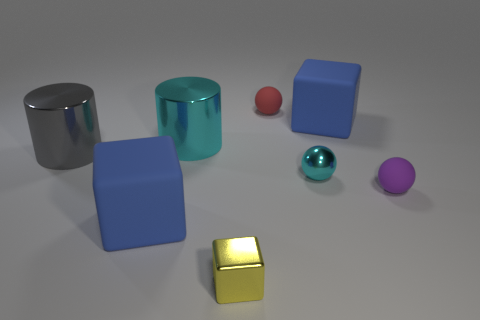What number of brown objects are metallic cylinders or tiny blocks?
Your answer should be very brief. 0. Is the number of big blue rubber objects that are left of the tiny purple thing less than the number of tiny purple balls that are behind the red thing?
Provide a succinct answer. No. Is there a red matte sphere that has the same size as the gray thing?
Offer a very short reply. No. Do the blue object that is in front of the cyan sphere and the purple sphere have the same size?
Give a very brief answer. No. Is the number of red things greater than the number of big brown blocks?
Make the answer very short. Yes. Are there any blue objects that have the same shape as the tiny purple matte thing?
Your answer should be compact. No. There is a tiny matte thing that is behind the big cyan shiny object; what is its shape?
Provide a succinct answer. Sphere. How many shiny objects are left of the blue cube that is to the left of the big blue matte block behind the large gray metallic object?
Make the answer very short. 1. There is a small ball to the right of the tiny shiny sphere; is it the same color as the tiny metallic sphere?
Keep it short and to the point. No. How many other objects are the same shape as the purple object?
Your answer should be very brief. 2. 